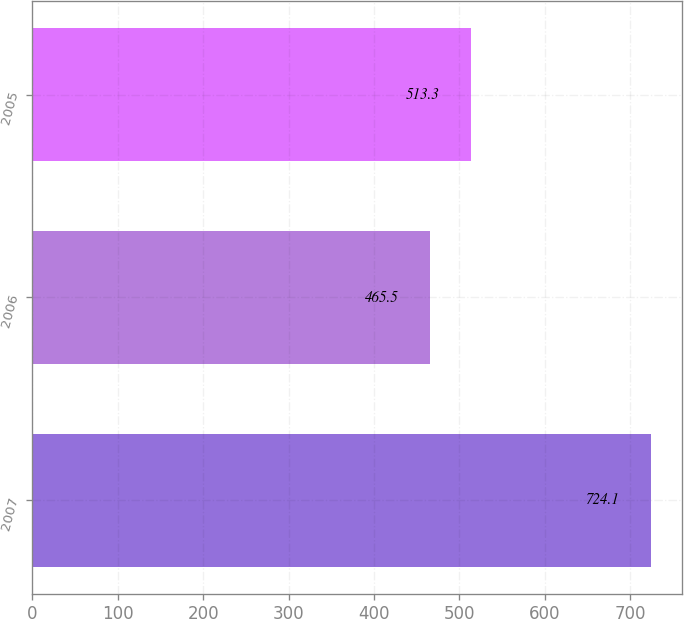<chart> <loc_0><loc_0><loc_500><loc_500><bar_chart><fcel>2007<fcel>2006<fcel>2005<nl><fcel>724.1<fcel>465.5<fcel>513.3<nl></chart> 